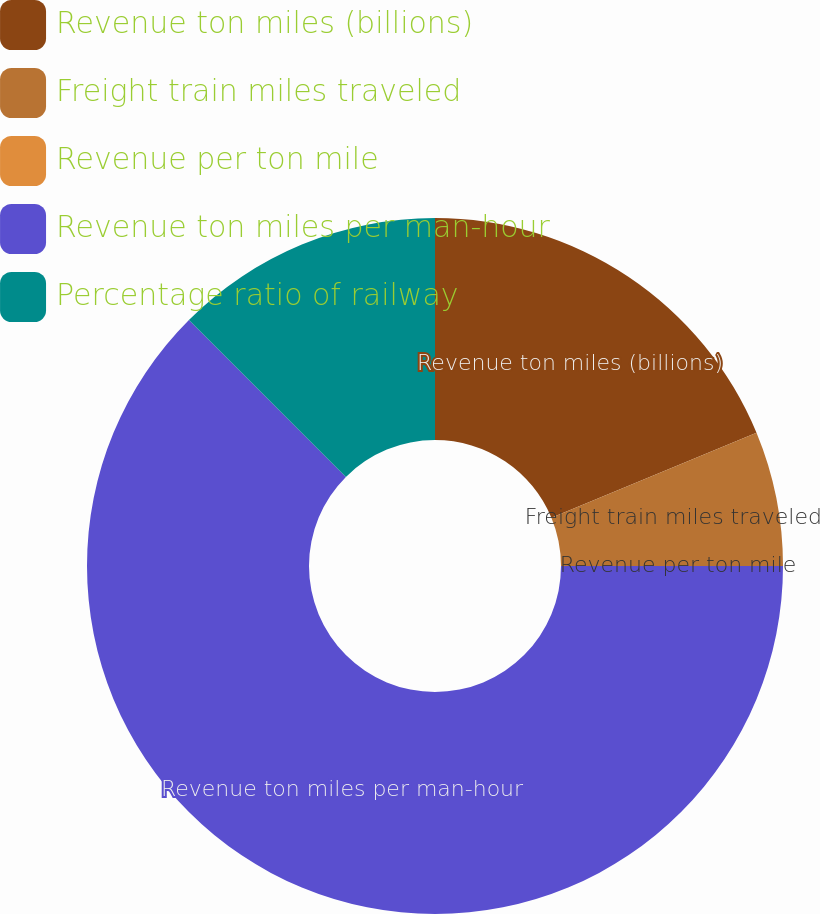Convert chart. <chart><loc_0><loc_0><loc_500><loc_500><pie_chart><fcel>Revenue ton miles (billions)<fcel>Freight train miles traveled<fcel>Revenue per ton mile<fcel>Revenue ton miles per man-hour<fcel>Percentage ratio of railway<nl><fcel>18.75%<fcel>6.25%<fcel>0.0%<fcel>62.5%<fcel>12.5%<nl></chart> 